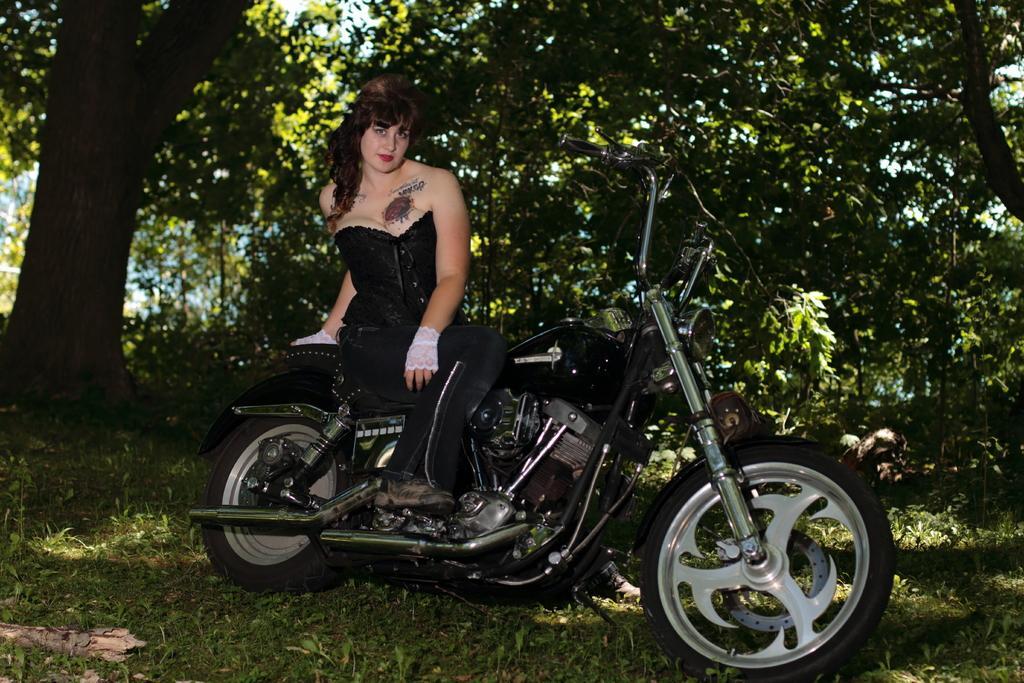Describe this image in one or two sentences. In the image there is a woman sitting on bike. In background there are some trees with green leaves at bottom there is a grass. 